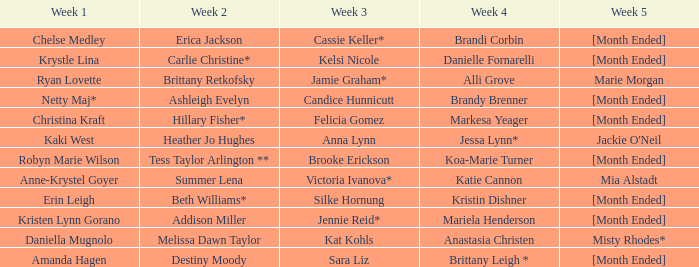What occurs during week 2 with daniella mugnolo after week 1? Melissa Dawn Taylor. 